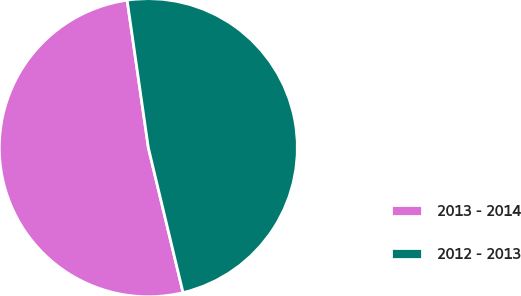Convert chart. <chart><loc_0><loc_0><loc_500><loc_500><pie_chart><fcel>2013 - 2014<fcel>2012 - 2013<nl><fcel>51.47%<fcel>48.53%<nl></chart> 